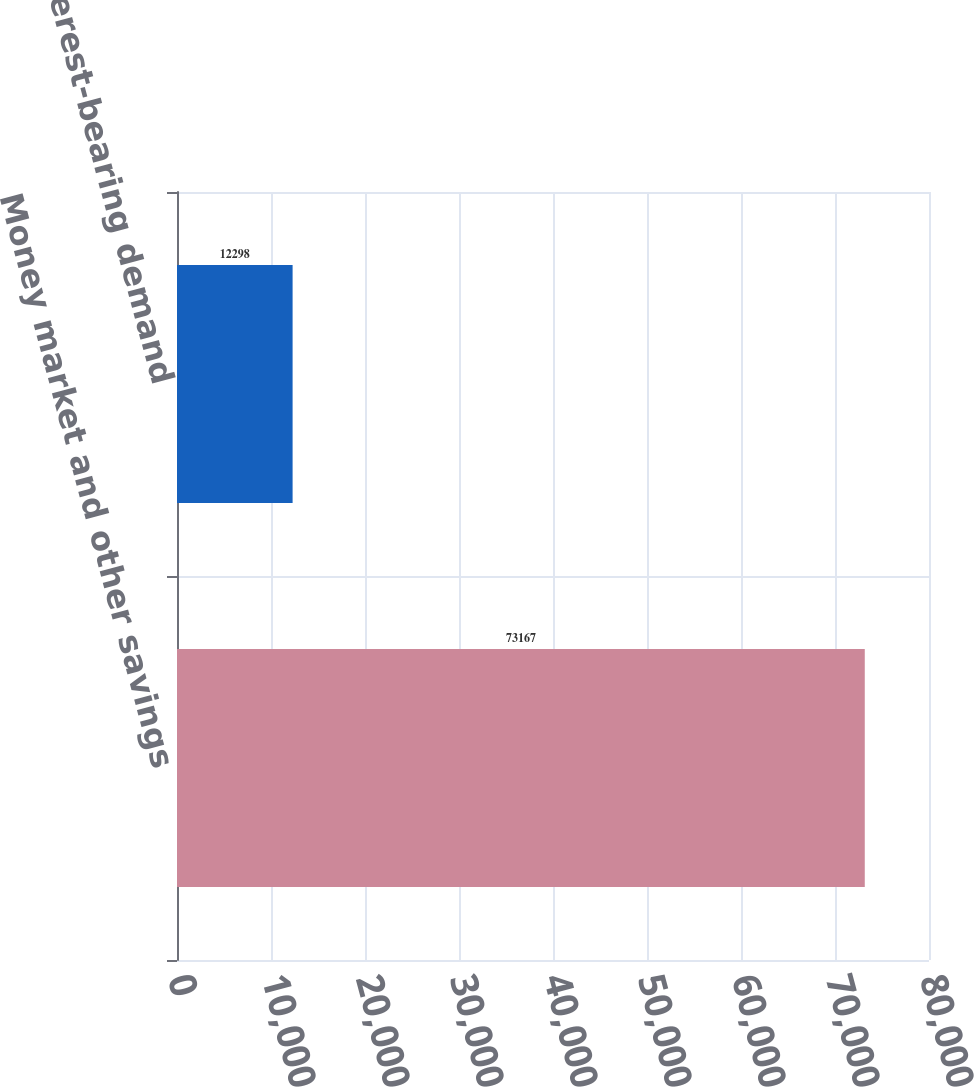Convert chart. <chart><loc_0><loc_0><loc_500><loc_500><bar_chart><fcel>Money market and other savings<fcel>Interest-bearing demand<nl><fcel>73167<fcel>12298<nl></chart> 